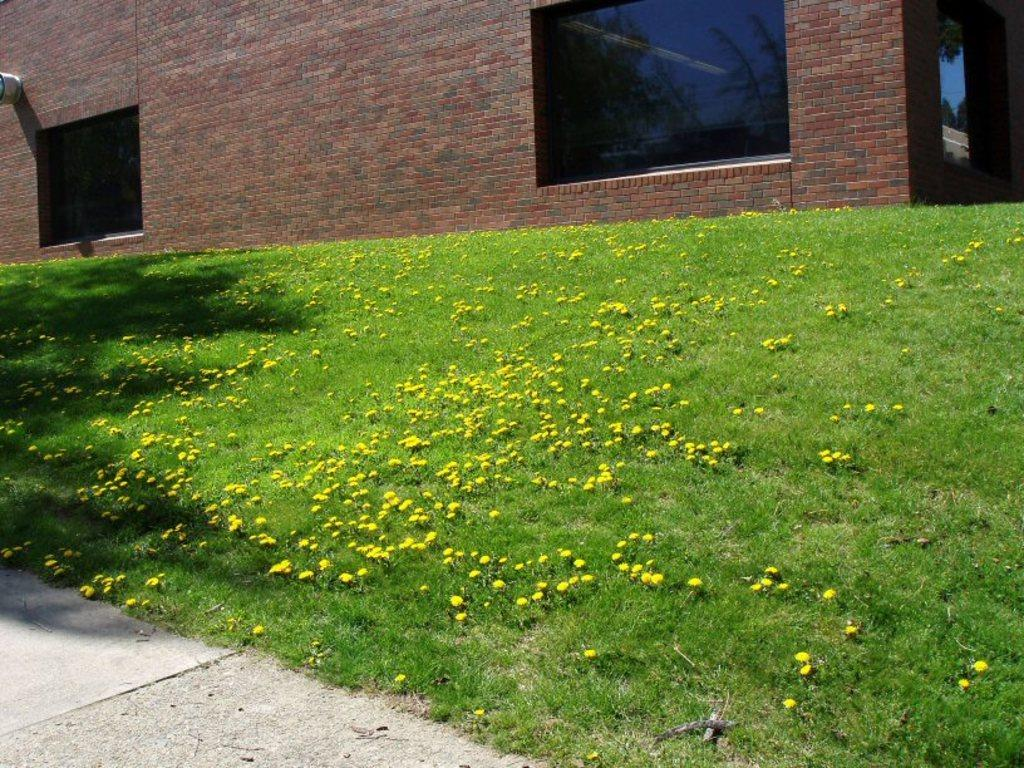What type of plants can be seen in the image? There are plants with flowers in the image. Where are the plants located? The plants are on a grassland. What can be seen in the background of the image? There is a wall with windows in the background of the image. What feature is visible in the left bottom of the image? There is a path visible in the left bottom of the image. What type of food is being served at the attraction in the image? There is no attraction or food present in the image; it features plants with flowers on a grassland with a wall and windows in the background. 